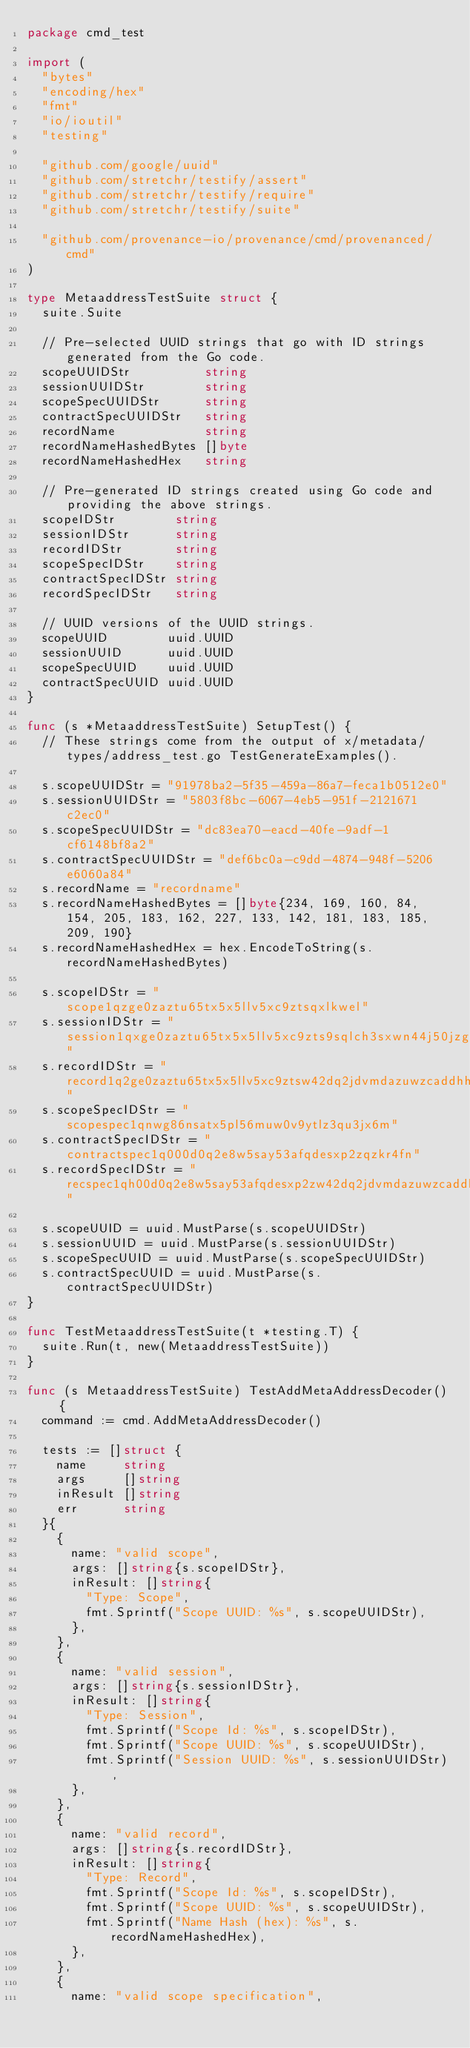Convert code to text. <code><loc_0><loc_0><loc_500><loc_500><_Go_>package cmd_test

import (
	"bytes"
	"encoding/hex"
	"fmt"
	"io/ioutil"
	"testing"

	"github.com/google/uuid"
	"github.com/stretchr/testify/assert"
	"github.com/stretchr/testify/require"
	"github.com/stretchr/testify/suite"

	"github.com/provenance-io/provenance/cmd/provenanced/cmd"
)

type MetaaddressTestSuite struct {
	suite.Suite

	// Pre-selected UUID strings that go with ID strings generated from the Go code.
	scopeUUIDStr          string
	sessionUUIDStr        string
	scopeSpecUUIDStr      string
	contractSpecUUIDStr   string
	recordName            string
	recordNameHashedBytes []byte
	recordNameHashedHex   string

	// Pre-generated ID strings created using Go code and providing the above strings.
	scopeIDStr        string
	sessionIDStr      string
	recordIDStr       string
	scopeSpecIDStr    string
	contractSpecIDStr string
	recordSpecIDStr   string

	// UUID versions of the UUID strings.
	scopeUUID        uuid.UUID
	sessionUUID      uuid.UUID
	scopeSpecUUID    uuid.UUID
	contractSpecUUID uuid.UUID
}

func (s *MetaaddressTestSuite) SetupTest() {
	// These strings come from the output of x/metadata/types/address_test.go TestGenerateExamples().

	s.scopeUUIDStr = "91978ba2-5f35-459a-86a7-feca1b0512e0"
	s.sessionUUIDStr = "5803f8bc-6067-4eb5-951f-2121671c2ec0"
	s.scopeSpecUUIDStr = "dc83ea70-eacd-40fe-9adf-1cf6148bf8a2"
	s.contractSpecUUIDStr = "def6bc0a-c9dd-4874-948f-5206e6060a84"
	s.recordName = "recordname"
	s.recordNameHashedBytes = []byte{234, 169, 160, 84, 154, 205, 183, 162, 227, 133, 142, 181, 183, 185, 209, 190}
	s.recordNameHashedHex = hex.EncodeToString(s.recordNameHashedBytes)

	s.scopeIDStr = "scope1qzge0zaztu65tx5x5llv5xc9ztsqxlkwel"
	s.sessionIDStr = "session1qxge0zaztu65tx5x5llv5xc9zts9sqlch3sxwn44j50jzgt8rshvqyfrjcr"
	s.recordIDStr = "record1q2ge0zaztu65tx5x5llv5xc9ztsw42dq2jdvmdazuwzcaddhh8gmu3mcze3"
	s.scopeSpecIDStr = "scopespec1qnwg86nsatx5pl56muw0v9ytlz3qu3jx6m"
	s.contractSpecIDStr = "contractspec1q000d0q2e8w5say53afqdesxp2zqzkr4fn"
	s.recordSpecIDStr = "recspec1qh00d0q2e8w5say53afqdesxp2zw42dq2jdvmdazuwzcaddhh8gmuqhez44"

	s.scopeUUID = uuid.MustParse(s.scopeUUIDStr)
	s.sessionUUID = uuid.MustParse(s.sessionUUIDStr)
	s.scopeSpecUUID = uuid.MustParse(s.scopeSpecUUIDStr)
	s.contractSpecUUID = uuid.MustParse(s.contractSpecUUIDStr)
}

func TestMetaaddressTestSuite(t *testing.T) {
	suite.Run(t, new(MetaaddressTestSuite))
}

func (s MetaaddressTestSuite) TestAddMetaAddressDecoder() {
	command := cmd.AddMetaAddressDecoder()

	tests := []struct {
		name     string
		args     []string
		inResult []string
		err      string
	}{
		{
			name: "valid scope",
			args: []string{s.scopeIDStr},
			inResult: []string{
				"Type: Scope",
				fmt.Sprintf("Scope UUID: %s", s.scopeUUIDStr),
			},
		},
		{
			name: "valid session",
			args: []string{s.sessionIDStr},
			inResult: []string{
				"Type: Session",
				fmt.Sprintf("Scope Id: %s", s.scopeIDStr),
				fmt.Sprintf("Scope UUID: %s", s.scopeUUIDStr),
				fmt.Sprintf("Session UUID: %s", s.sessionUUIDStr),
			},
		},
		{
			name: "valid record",
			args: []string{s.recordIDStr},
			inResult: []string{
				"Type: Record",
				fmt.Sprintf("Scope Id: %s", s.scopeIDStr),
				fmt.Sprintf("Scope UUID: %s", s.scopeUUIDStr),
				fmt.Sprintf("Name Hash (hex): %s", s.recordNameHashedHex),
			},
		},
		{
			name: "valid scope specification",</code> 